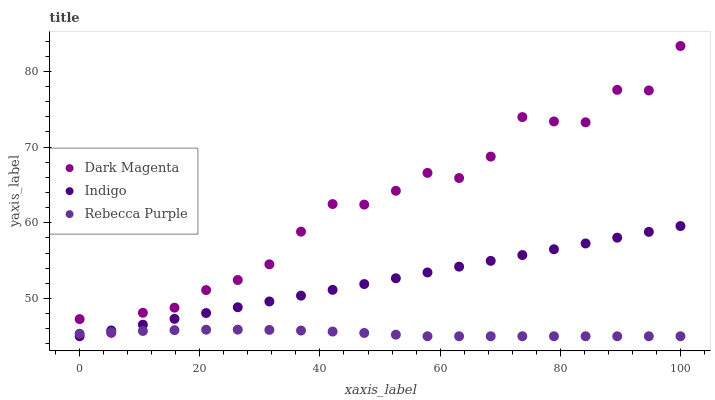Does Rebecca Purple have the minimum area under the curve?
Answer yes or no. Yes. Does Dark Magenta have the maximum area under the curve?
Answer yes or no. Yes. Does Dark Magenta have the minimum area under the curve?
Answer yes or no. No. Does Rebecca Purple have the maximum area under the curve?
Answer yes or no. No. Is Indigo the smoothest?
Answer yes or no. Yes. Is Dark Magenta the roughest?
Answer yes or no. Yes. Is Rebecca Purple the smoothest?
Answer yes or no. No. Is Rebecca Purple the roughest?
Answer yes or no. No. Does Indigo have the lowest value?
Answer yes or no. Yes. Does Dark Magenta have the lowest value?
Answer yes or no. No. Does Dark Magenta have the highest value?
Answer yes or no. Yes. Does Rebecca Purple have the highest value?
Answer yes or no. No. Does Dark Magenta intersect Rebecca Purple?
Answer yes or no. Yes. Is Dark Magenta less than Rebecca Purple?
Answer yes or no. No. Is Dark Magenta greater than Rebecca Purple?
Answer yes or no. No. 